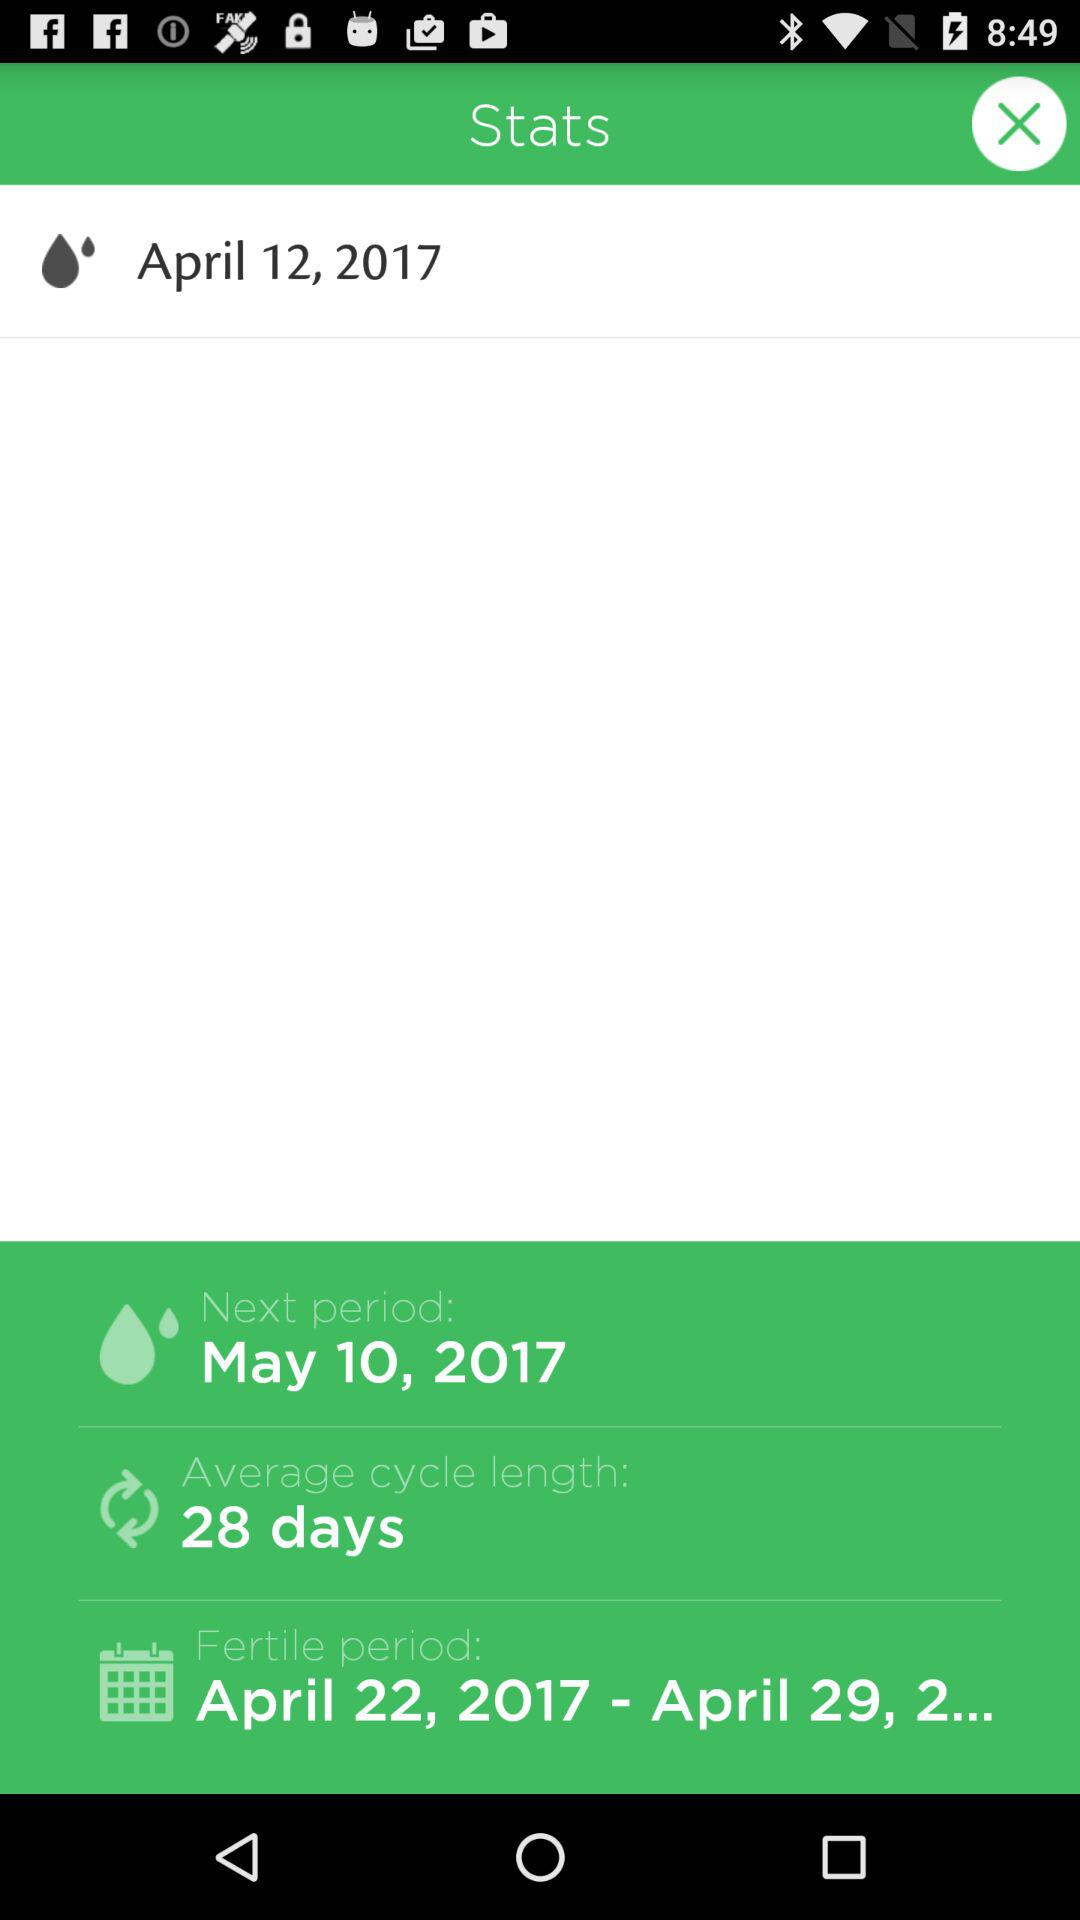What is the difference between the start and end date of the fertile period?
Answer the question using a single word or phrase. 7 days 